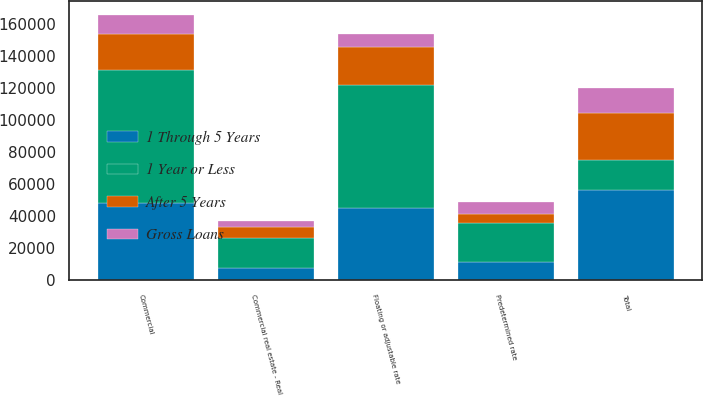<chart> <loc_0><loc_0><loc_500><loc_500><stacked_bar_chart><ecel><fcel>Commercial<fcel>Commercial real estate - Real<fcel>Total<fcel>Predetermined rate<fcel>Floating or adjustable rate<nl><fcel>After 5 Years<fcel>22804<fcel>6575<fcel>29379<fcel>5458<fcel>23921<nl><fcel>1 Through 5 Years<fcel>48428<fcel>8070<fcel>56498<fcel>11320<fcel>45178<nl><fcel>Gross Loans<fcel>11808<fcel>4010<fcel>15818<fcel>7855<fcel>7963<nl><fcel>1 Year or Less<fcel>83040<fcel>18655<fcel>18655<fcel>24633<fcel>77062<nl></chart> 